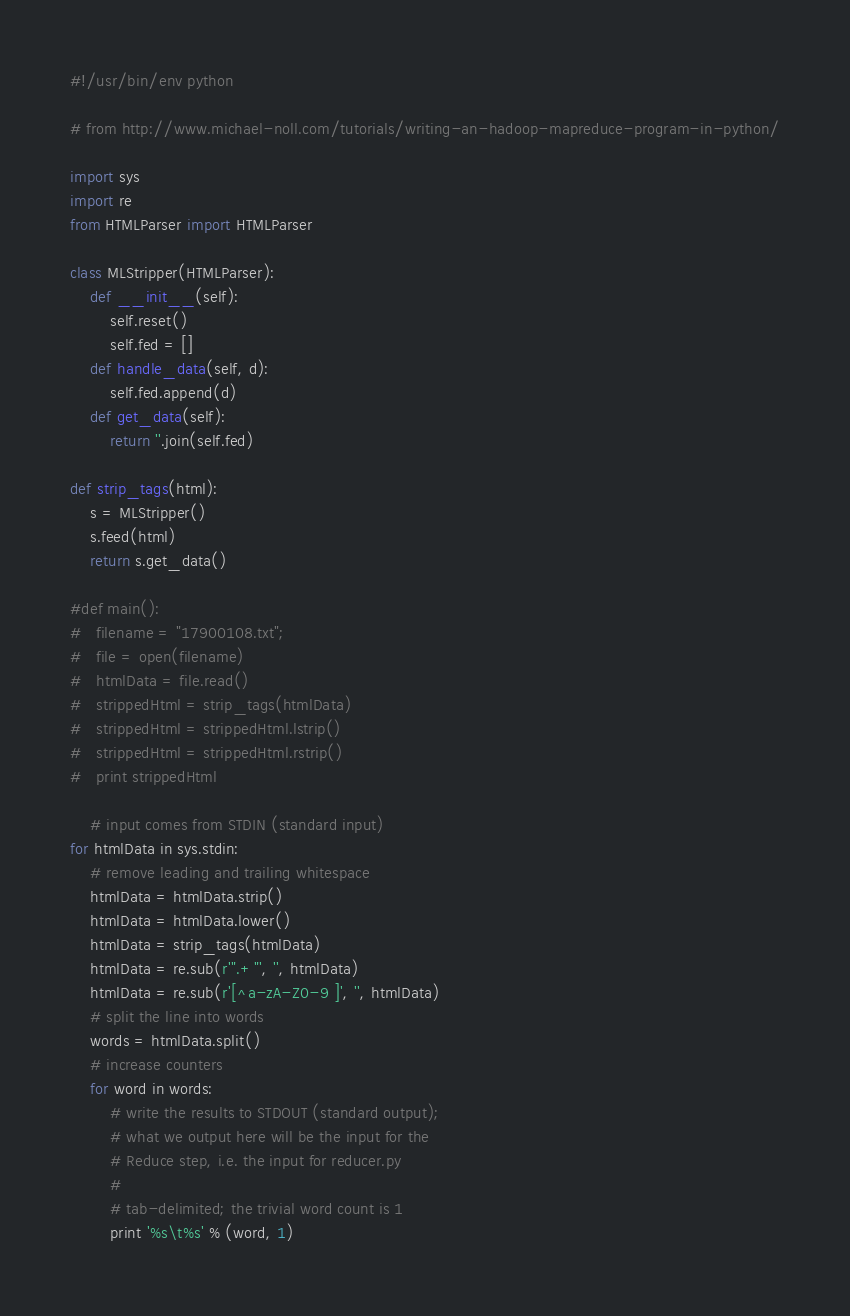Convert code to text. <code><loc_0><loc_0><loc_500><loc_500><_Python_>#!/usr/bin/env python

# from http://www.michael-noll.com/tutorials/writing-an-hadoop-mapreduce-program-in-python/

import sys
import re
from HTMLParser import HTMLParser

class MLStripper(HTMLParser):
    def __init__(self):
        self.reset()
        self.fed = []
    def handle_data(self, d):
        self.fed.append(d)
    def get_data(self):
        return ''.join(self.fed)

def strip_tags(html):
    s = MLStripper()
    s.feed(html)
    return s.get_data()
	
#def main():
#	filename = "17900108.txt";
#	file = open(filename)
#	htmlData = file.read()
#	strippedHtml = strip_tags(htmlData)
#	strippedHtml = strippedHtml.lstrip()
#	strippedHtml = strippedHtml.rstrip()
#	print strippedHtml
	
	# input comes from STDIN (standard input)
for htmlData in sys.stdin:
    # remove leading and trailing whitespace
    htmlData = htmlData.strip()
    htmlData = htmlData.lower()
    htmlData = strip_tags(htmlData)
    htmlData = re.sub(r'".+"', '', htmlData)
    htmlData = re.sub(r'[^a-zA-Z0-9 ]', '', htmlData)
    # split the line into words
    words = htmlData.split()
    # increase counters
    for word in words:
        # write the results to STDOUT (standard output);
        # what we output here will be the input for the
        # Reduce step, i.e. the input for reducer.py
        #
        # tab-delimited; the trivial word count is 1
        print '%s\t%s' % (word, 1)
</code> 